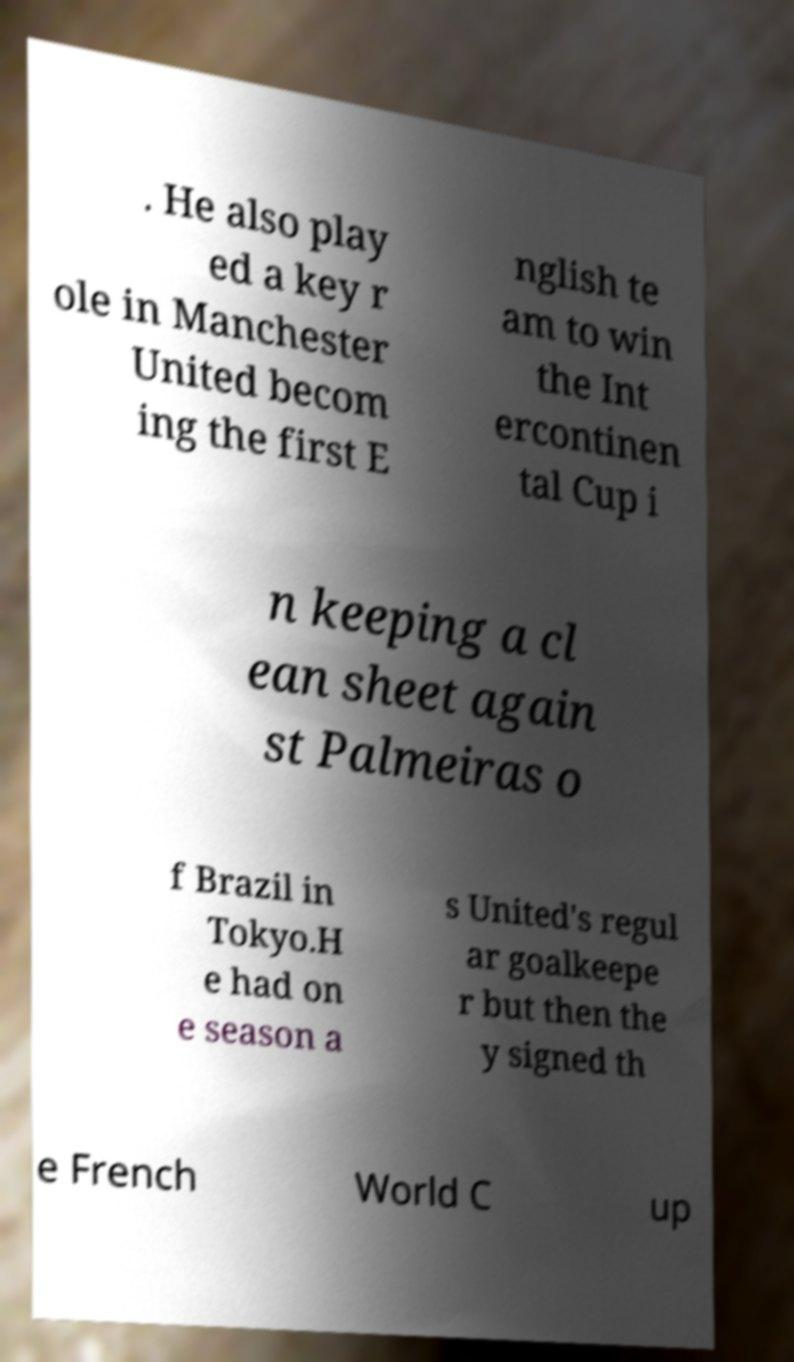Could you assist in decoding the text presented in this image and type it out clearly? . He also play ed a key r ole in Manchester United becom ing the first E nglish te am to win the Int ercontinen tal Cup i n keeping a cl ean sheet again st Palmeiras o f Brazil in Tokyo.H e had on e season a s United's regul ar goalkeepe r but then the y signed th e French World C up 